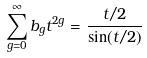<formula> <loc_0><loc_0><loc_500><loc_500>\sum _ { g = 0 } ^ { \infty } b _ { g } t ^ { 2 g } = \frac { t / 2 } { \sin ( t / 2 ) }</formula> 